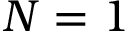Convert formula to latex. <formula><loc_0><loc_0><loc_500><loc_500>N = 1</formula> 